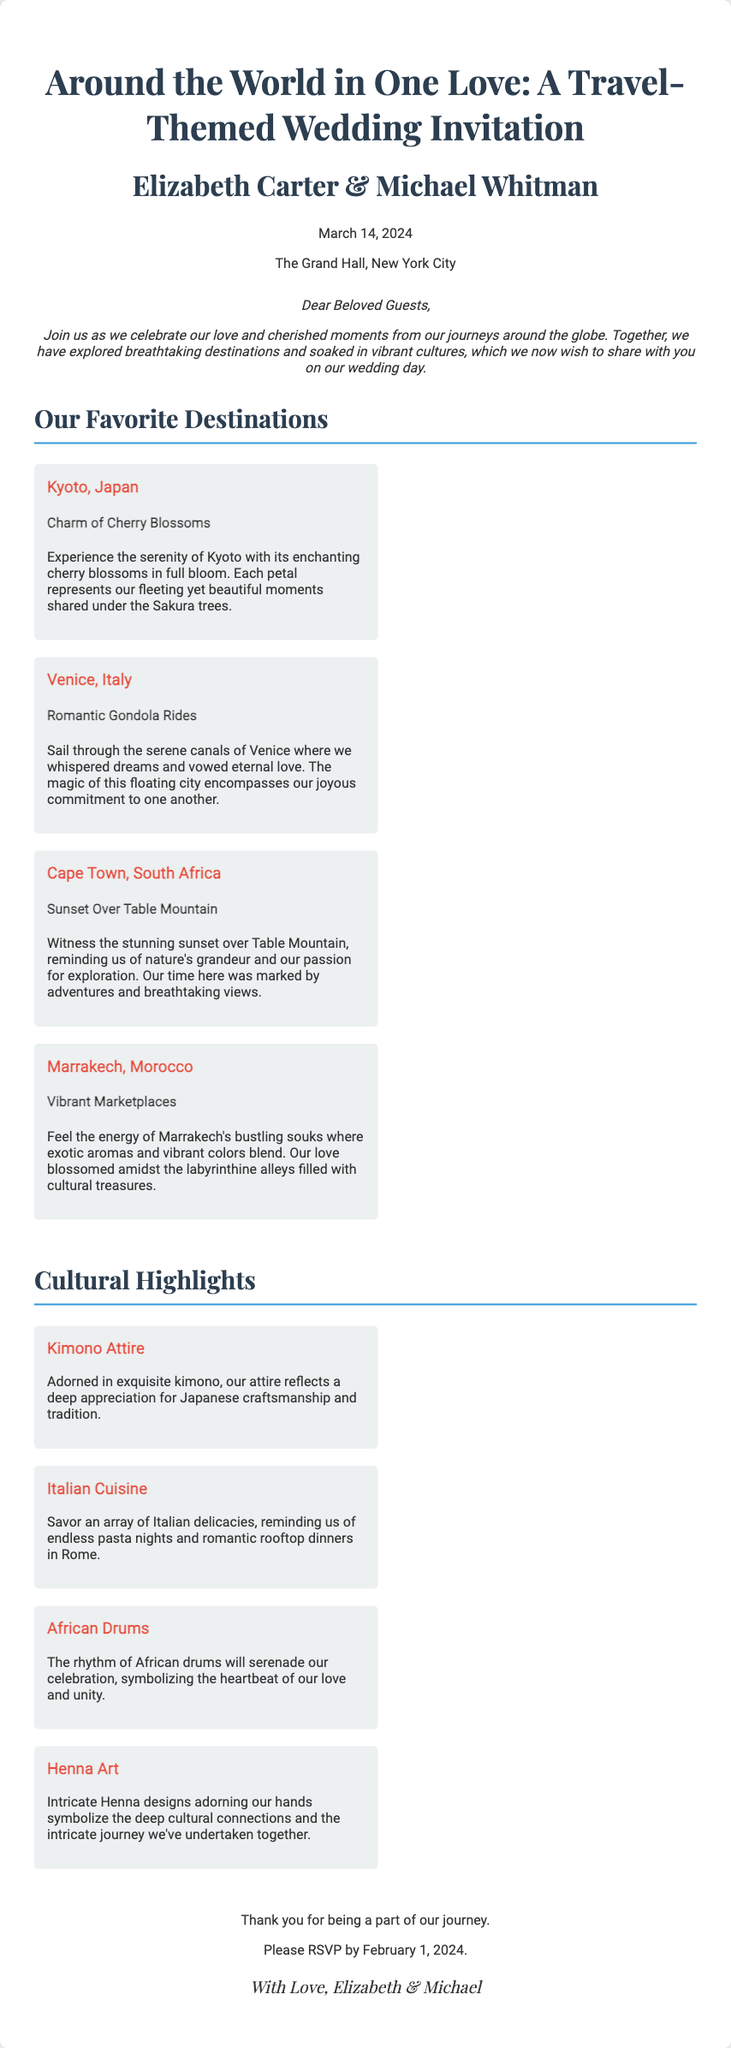What is the date of the wedding? The date of the wedding is mentioned in the document as March 14, 2024.
Answer: March 14, 2024 Who are the couple getting married? The couple's names are highlighted in the document as Elizabeth Carter and Michael Whitman.
Answer: Elizabeth Carter & Michael Whitman What venue will the wedding be held at? The wedding venue is stated in the document as The Grand Hall, New York City.
Answer: The Grand Hall, New York City What is the RSVP deadline? The document specifies that the RSVP deadline is February 1, 2024.
Answer: February 1, 2024 Which destination is known for its cherry blossoms? The destination associated with cherry blossoms is mentioned in the document as Kyoto, Japan.
Answer: Kyoto, Japan What cultural highlight represents a deep appreciation for Japanese craftsmanship? The cultural highlight that represents Japanese craftsmanship is kimono attire.
Answer: Kimono Attire What romantic experience is highlighted in Venice? The document mentions romantic gondola rides as a highlighted experience in Venice.
Answer: Romantic Gondola Rides Which cultural element symbolizes the heartbeat of love and unity? The cultural element that symbolizes the heartbeat of love and unity is African drums.
Answer: African Drums In which destination did the couple experience a sunset over Table Mountain? The document states that the sunset over Table Mountain is experienced in Cape Town, South Africa.
Answer: Cape Town, South Africa 